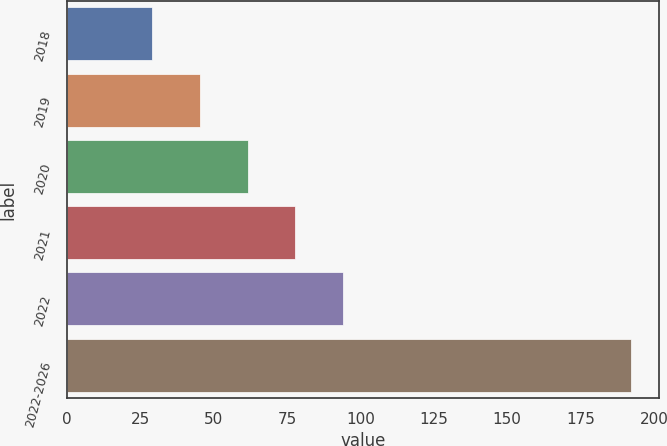<chart> <loc_0><loc_0><loc_500><loc_500><bar_chart><fcel>2018<fcel>2019<fcel>2020<fcel>2021<fcel>2022<fcel>2022-2026<nl><fcel>29<fcel>45.3<fcel>61.6<fcel>77.9<fcel>94.2<fcel>192<nl></chart> 